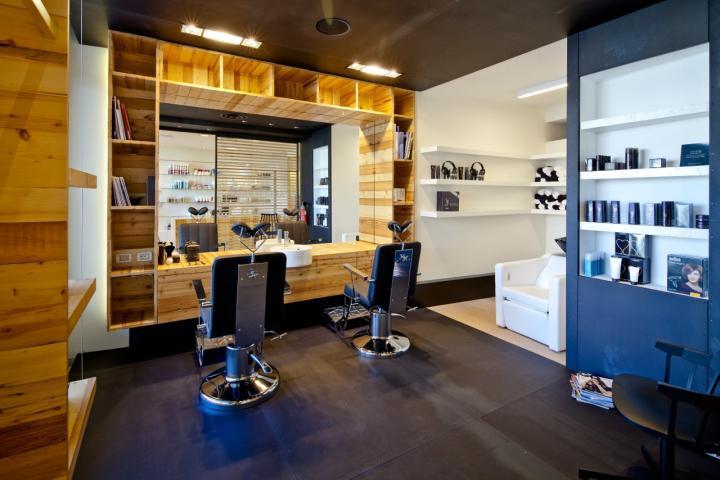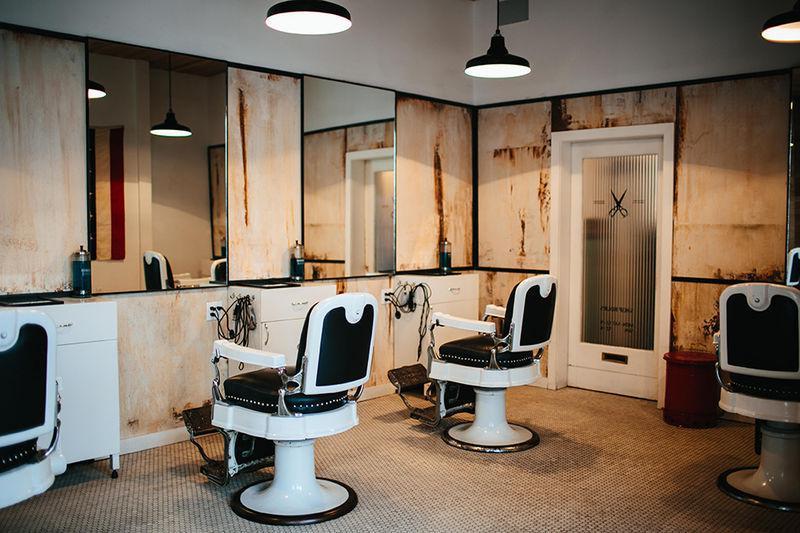The first image is the image on the left, the second image is the image on the right. Given the left and right images, does the statement "In at least one image, a row of barber shop chairs sits on an intricate tiled floor." hold true? Answer yes or no. No. 